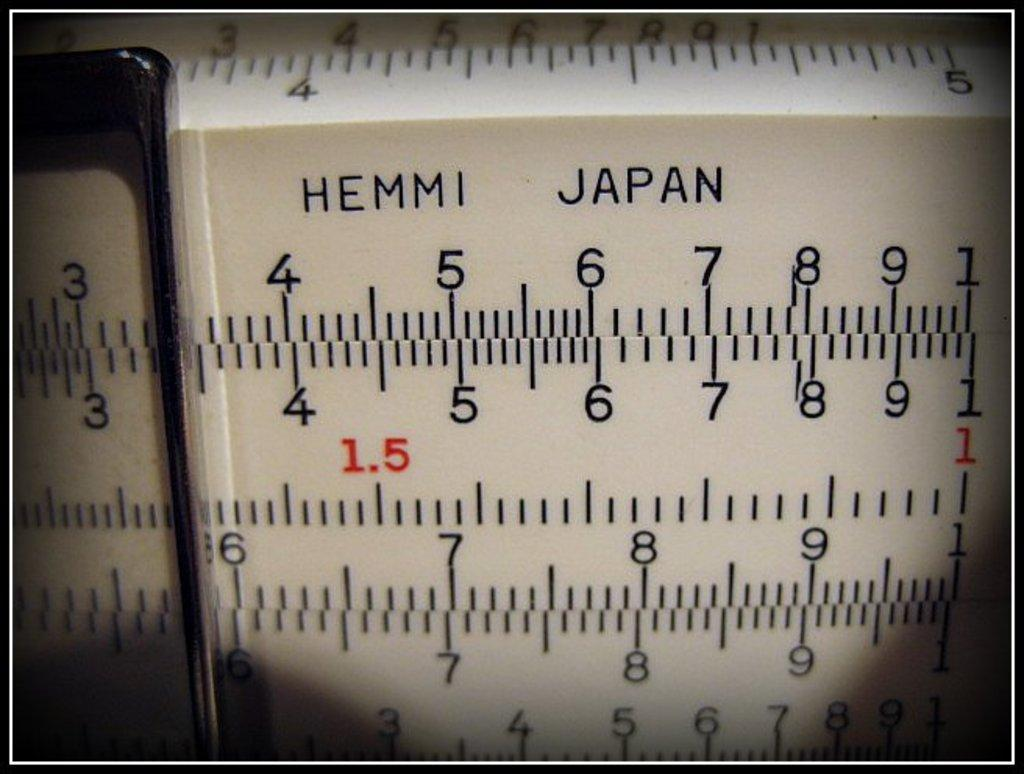<image>
Summarize the visual content of the image. Several rows of numbers and lines that say Hemmi Japan at the top. 